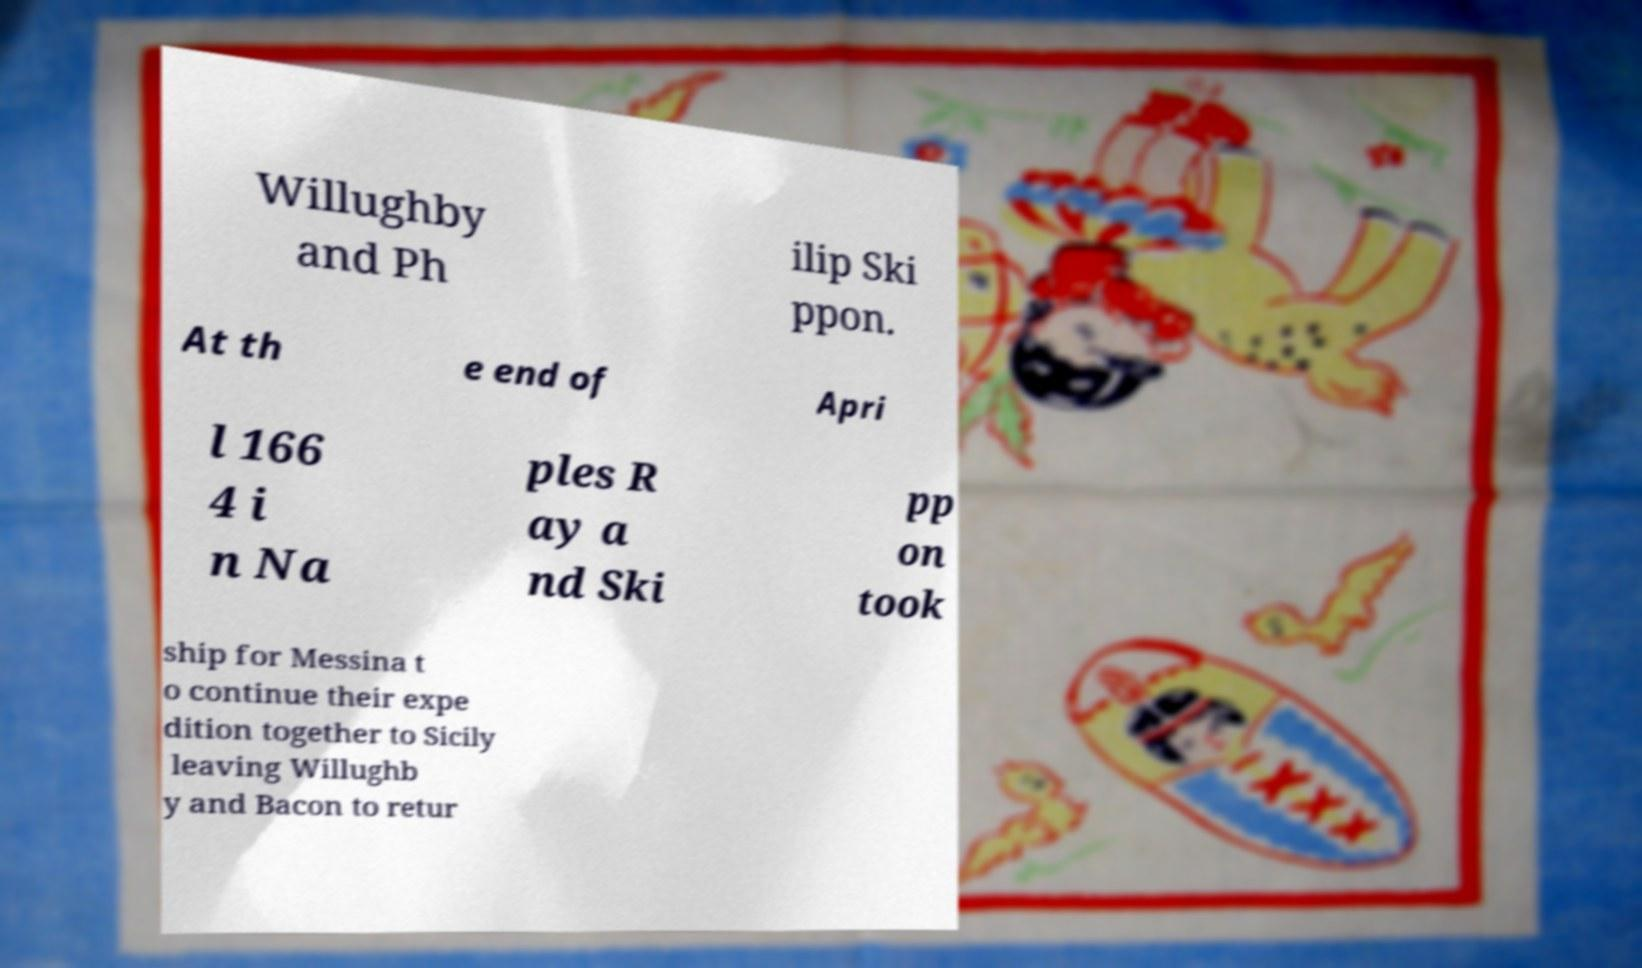Can you accurately transcribe the text from the provided image for me? Willughby and Ph ilip Ski ppon. At th e end of Apri l 166 4 i n Na ples R ay a nd Ski pp on took ship for Messina t o continue their expe dition together to Sicily leaving Willughb y and Bacon to retur 